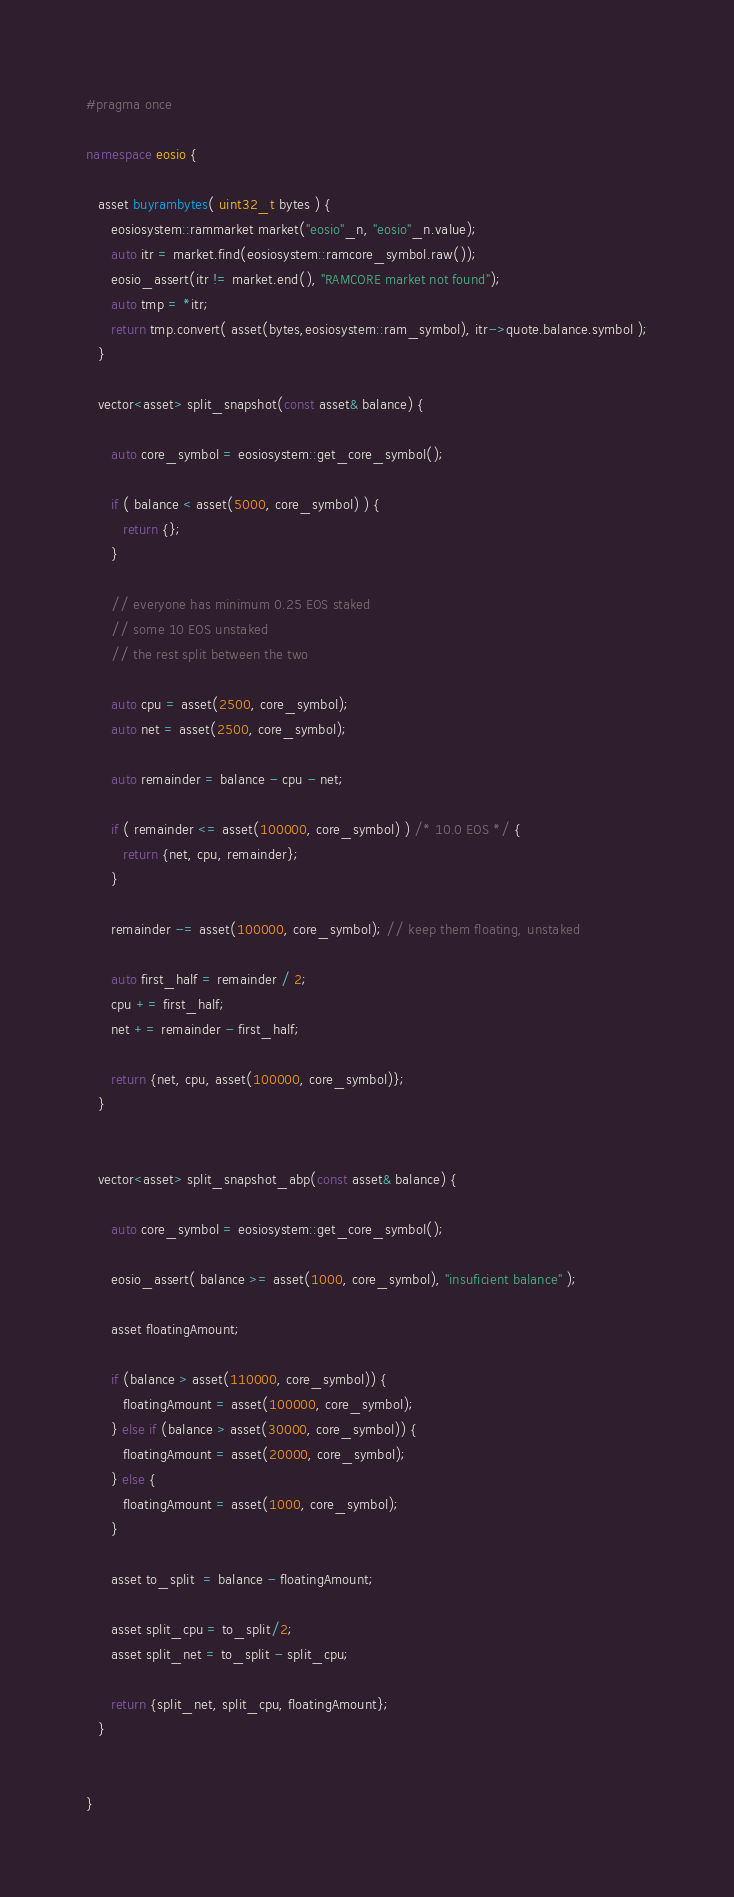<code> <loc_0><loc_0><loc_500><loc_500><_C++_>#pragma once

namespace eosio {

   asset buyrambytes( uint32_t bytes ) {
      eosiosystem::rammarket market("eosio"_n, "eosio"_n.value);
      auto itr = market.find(eosiosystem::ramcore_symbol.raw());
      eosio_assert(itr != market.end(), "RAMCORE market not found");
      auto tmp = *itr;
      return tmp.convert( asset(bytes,eosiosystem::ram_symbol), itr->quote.balance.symbol );
   }

   vector<asset> split_snapshot(const asset& balance) {
      
      auto core_symbol = eosiosystem::get_core_symbol();

      if ( balance < asset(5000, core_symbol) ) {
         return {};
      }

      // everyone has minimum 0.25 EOS staked
      // some 10 EOS unstaked
      // the rest split between the two

      auto cpu = asset(2500, core_symbol);
      auto net = asset(2500, core_symbol);

      auto remainder = balance - cpu - net;

      if ( remainder <= asset(100000, core_symbol) ) /* 10.0 EOS */ {
         return {net, cpu, remainder};
      }

      remainder -= asset(100000, core_symbol); // keep them floating, unstaked

      auto first_half = remainder / 2;
      cpu += first_half;
      net += remainder - first_half;

      return {net, cpu, asset(100000, core_symbol)};
   }


   vector<asset> split_snapshot_abp(const asset& balance) {
      
      auto core_symbol = eosiosystem::get_core_symbol();

      eosio_assert( balance >= asset(1000, core_symbol), "insuficient balance" );

      asset floatingAmount;

      if (balance > asset(110000, core_symbol)) { 
         floatingAmount = asset(100000, core_symbol);
      } else if (balance > asset(30000, core_symbol)) { 
         floatingAmount = asset(20000, core_symbol); 
      } else { 
         floatingAmount = asset(1000, core_symbol);
      }

      asset to_split  = balance - floatingAmount;
      
      asset split_cpu = to_split/2; 
      asset split_net = to_split - split_cpu;

      return {split_net, split_cpu, floatingAmount};
   }


}</code> 